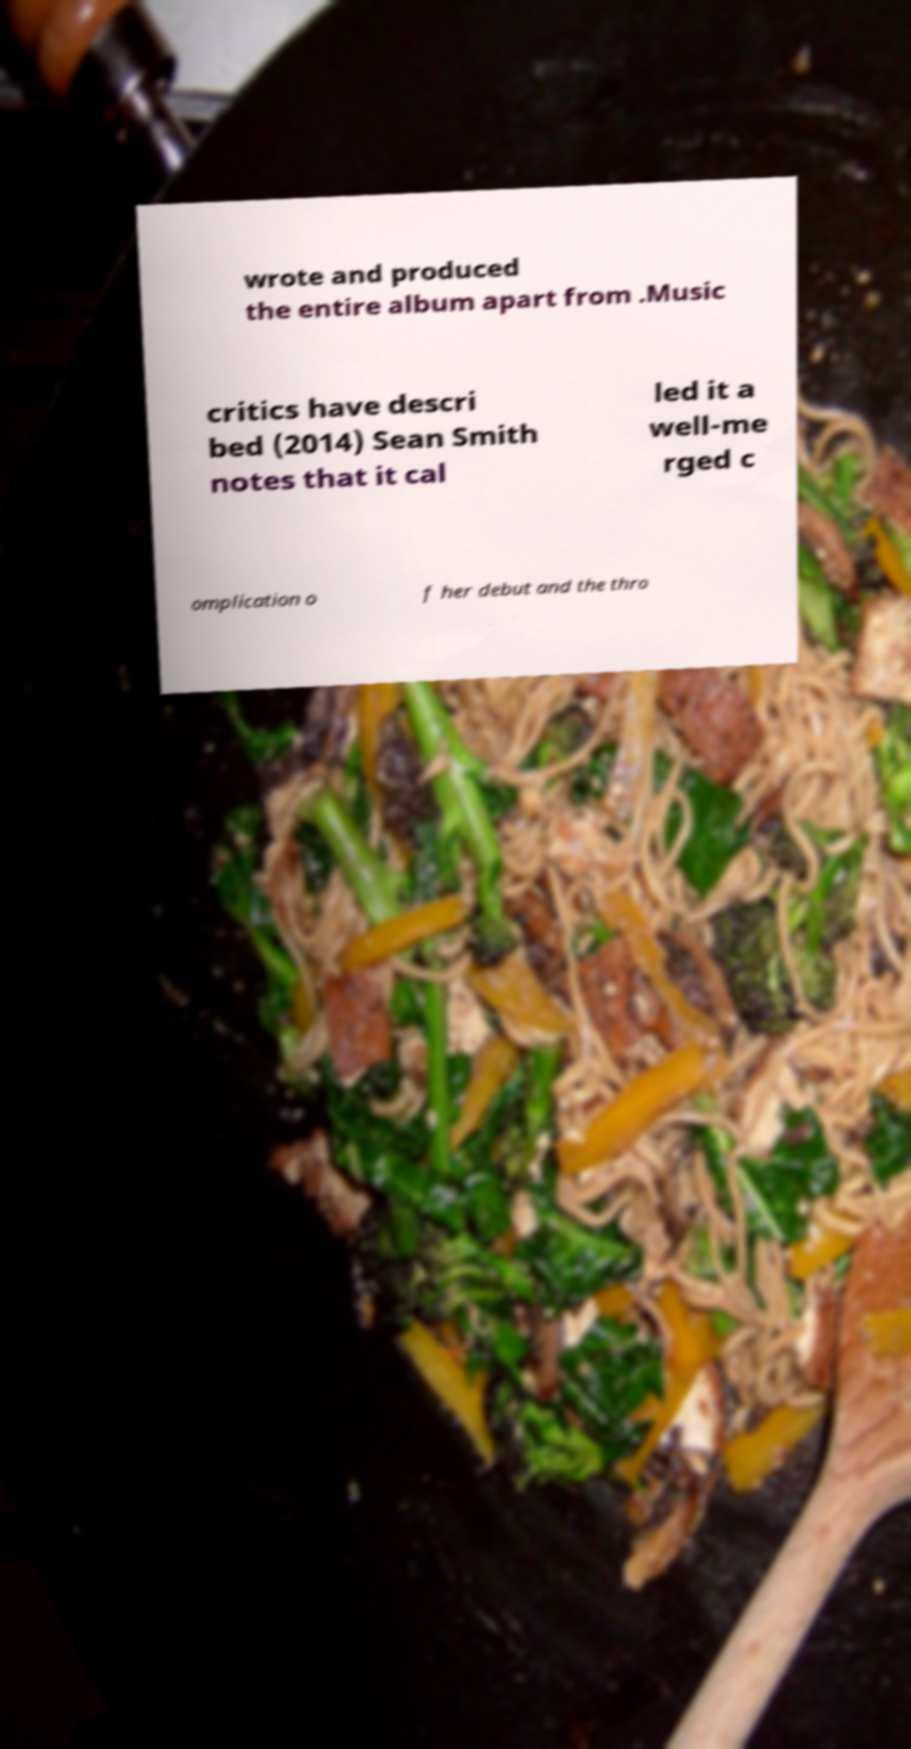Can you accurately transcribe the text from the provided image for me? wrote and produced the entire album apart from .Music critics have descri bed (2014) Sean Smith notes that it cal led it a well-me rged c omplication o f her debut and the thro 